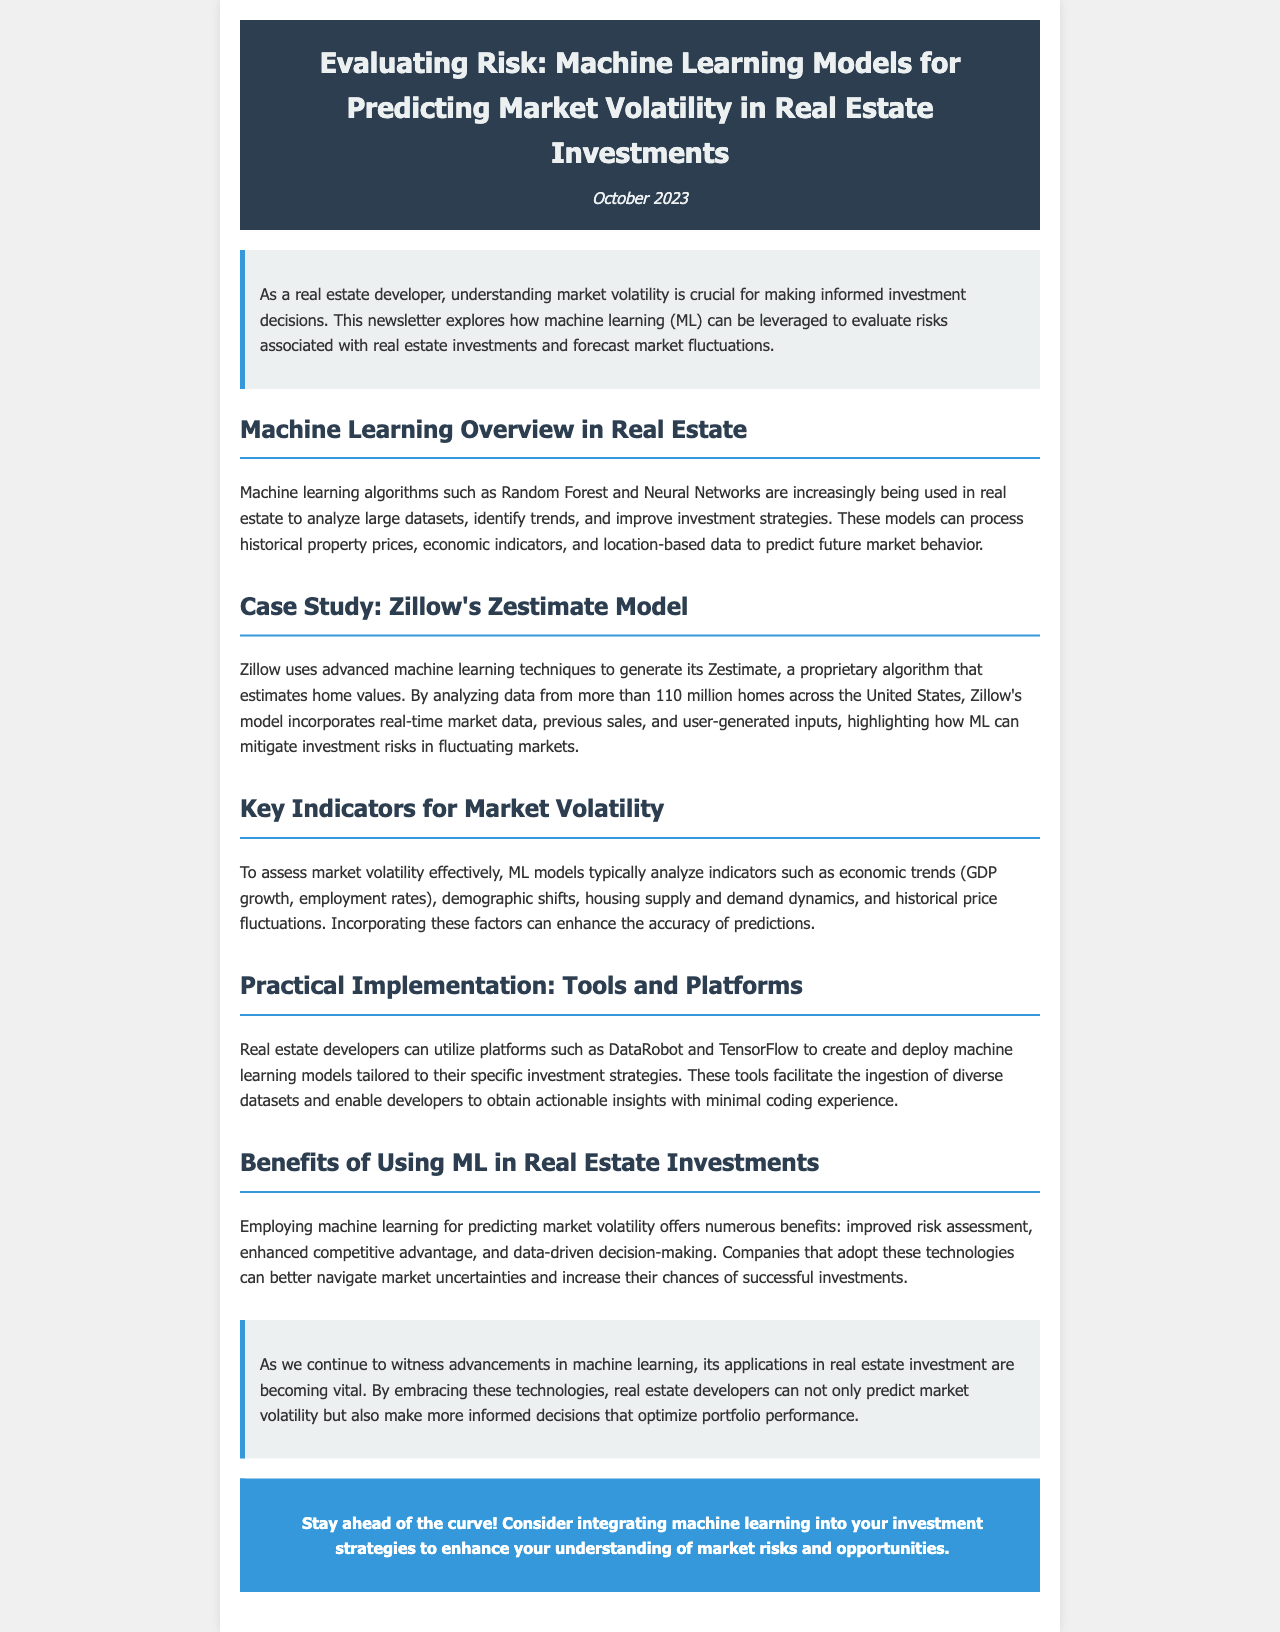What is the title of the newsletter? The title of the newsletter is presented in the header section of the document.
Answer: Evaluating Risk: Machine Learning Models for Predicting Market Volatility in Real Estate Investments When was the newsletter published? The publication date can be found in the date section below the title.
Answer: October 2023 Which machine learning algorithms are mentioned in the newsletter? The algorithms are outlined in the Machine Learning Overview section of the document.
Answer: Random Forest and Neural Networks How many homes does Zillow analyze for its Zestimate model? This information is provided in the case study section related to Zillow's Zestimate.
Answer: more than 110 million homes What key indicators are suggested for assessing market volatility? The indicators are listed in the Key Indicators for Market Volatility section.
Answer: economic trends, demographic shifts, housing supply and demand dynamics, historical price fluctuations What is one benefit of using ML in real estate investments? The benefits are enumerated in the Benefits of Using ML in Real Estate Investments section.
Answer: improved risk assessment What tools can real estate developers use for machine learning models? The practical implementation section mentions specific platforms suited for developers.
Answer: DataRobot and TensorFlow Why is integrating machine learning important for real estate developers? The conclusion of the document expounds on this significance.
Answer: optimize portfolio performance What type of content does this document represent? This pertains to the classification of the document presented.
Answer: newsletter 